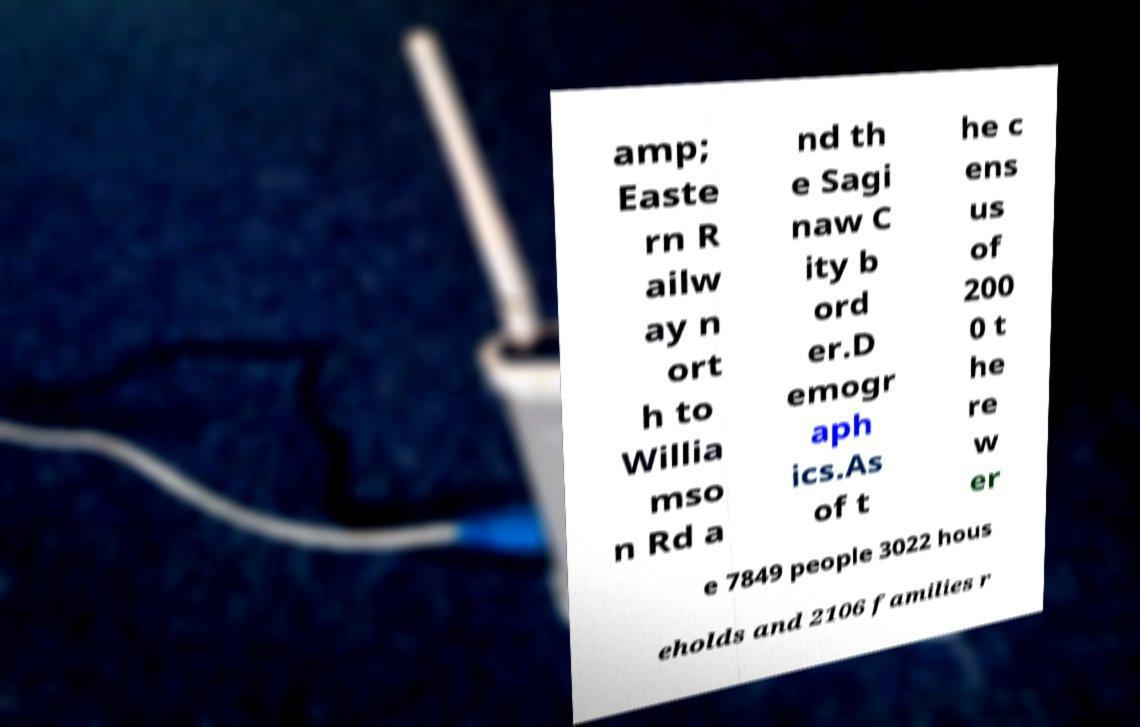What messages or text are displayed in this image? I need them in a readable, typed format. amp; Easte rn R ailw ay n ort h to Willia mso n Rd a nd th e Sagi naw C ity b ord er.D emogr aph ics.As of t he c ens us of 200 0 t he re w er e 7849 people 3022 hous eholds and 2106 families r 